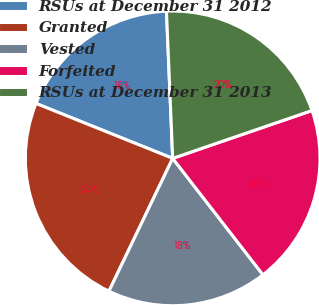<chart> <loc_0><loc_0><loc_500><loc_500><pie_chart><fcel>RSUs at December 31 2012<fcel>Granted<fcel>Vested<fcel>Forfeited<fcel>RSUs at December 31 2013<nl><fcel>18.25%<fcel>23.96%<fcel>17.62%<fcel>19.77%<fcel>20.41%<nl></chart> 